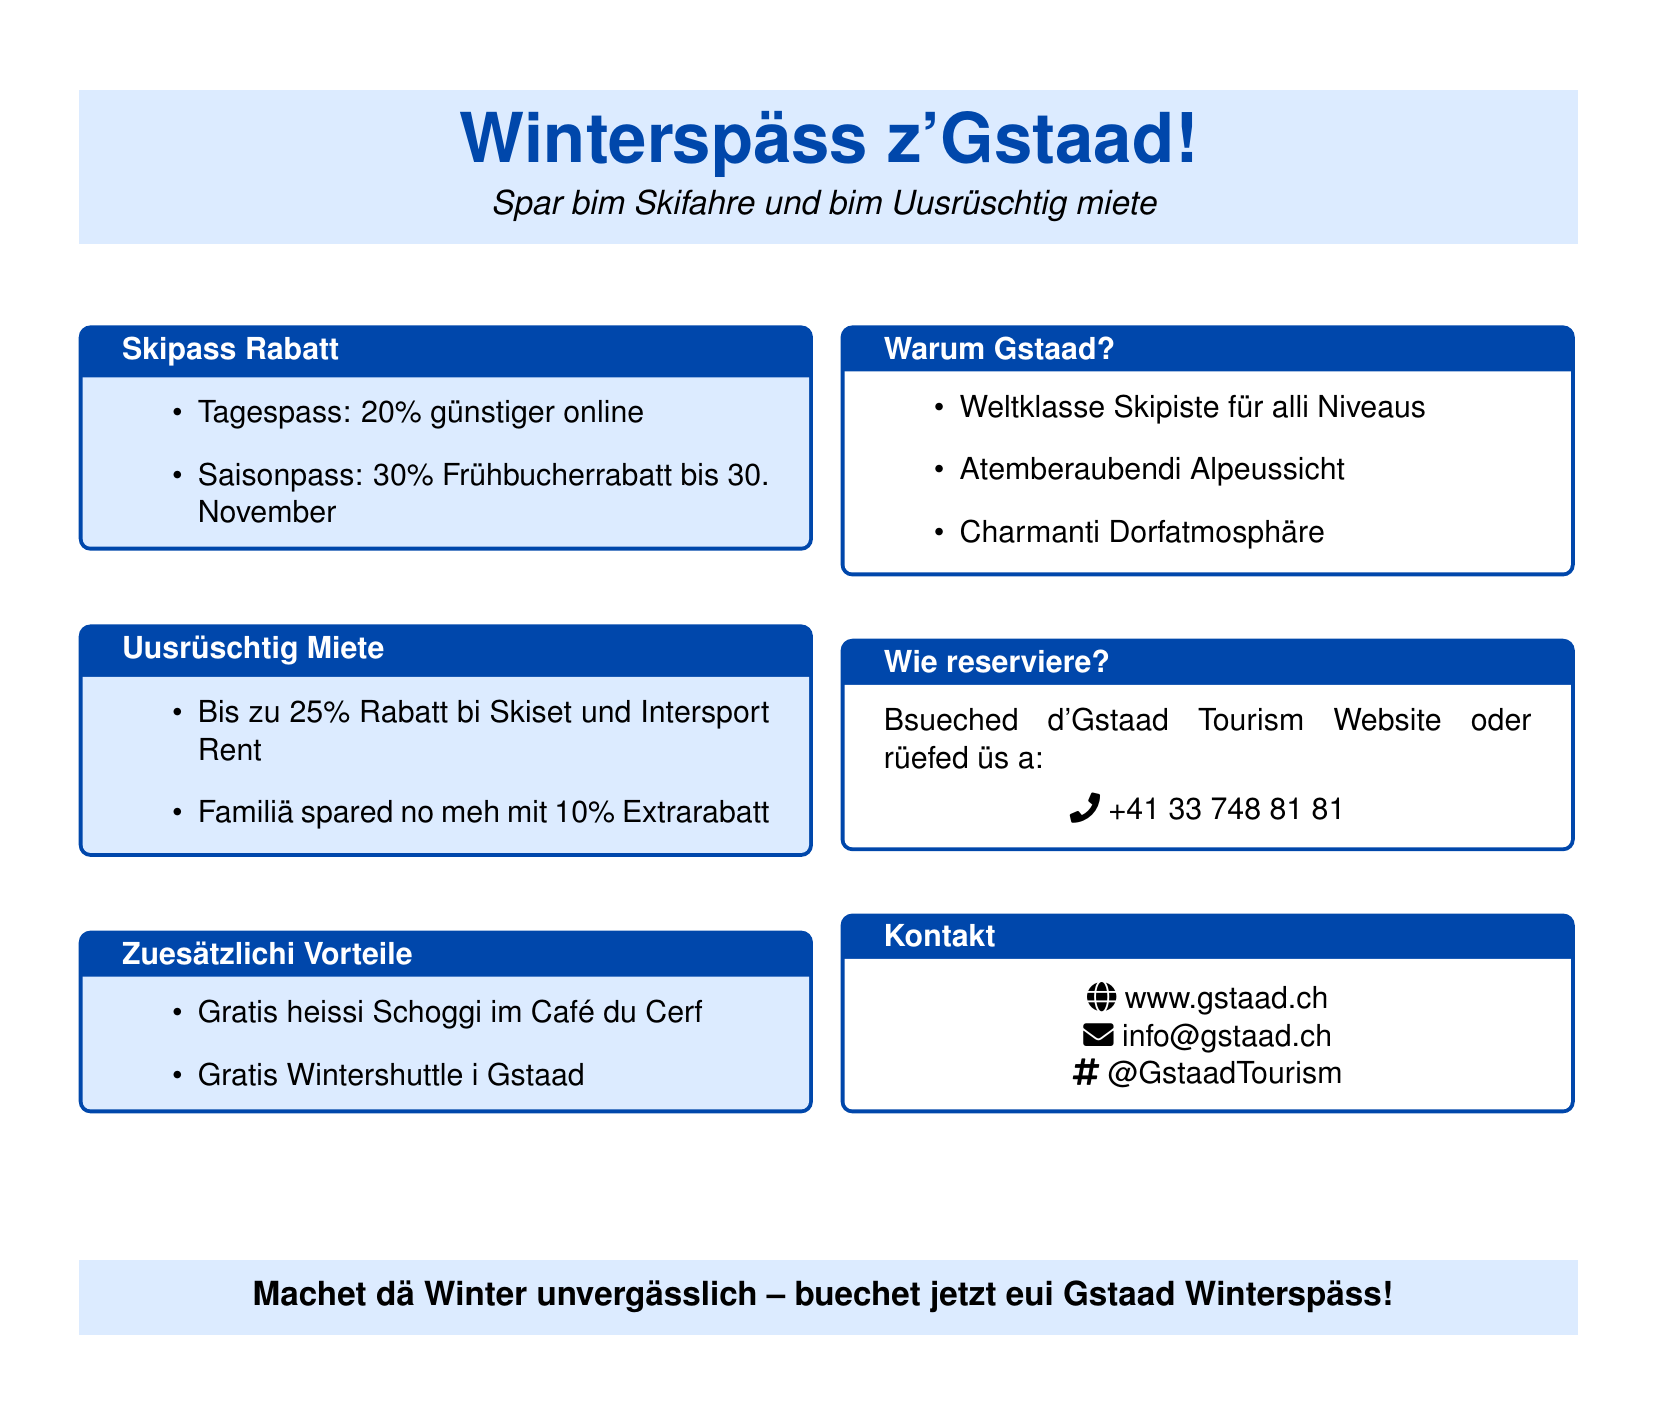Was isch der Rabatt für en Tagespass? Der Rabatt für en Tagespass isch 20 Prozent, wenn er online buecht wird.
Answer: 20% Was isch der Rabatt für e Familiä bim Uusrüschtig? Die Familiä spare no meh mit 10 Prozent Extrarabatt.
Answer: 10% Was hänn mir im Café du Cerf gratis? Im Café du Cerf gibt's gratis heissi Schoggi.
Answer: heissi Schoggi Wiel isch der Frühbucherrabatt für de Saisonpass gültig? Der Frühbucherrabatt für de Saisonpass isch gültig bis am 30. November.
Answer: 30. November Was chönd ihr mache, um z' reserviere? Z' reserviere chönd ihr d'Gstaad Tourism Website bsueched oder anrufen.
Answer: Website oder anrufen Wieviel Rabatt gibt’s bi Skiset und Intersport Rent? Es gibt bis zu 25 Prozent Rabatt bi Skiset und Intersport Rent.
Answer: 25% Was chönd mir bewundere, wenn mir in Gstaad sind? In Gstaad chönd mir atemberaubendi Alpeussicht bewundere.
Answer: Alpeussicht Was isch der Telefonnummer fürs Reserviere? Die Telefonnummer fürs Reserviere isch +41 33 748 81 81.
Answer: +41 33 748 81 81 